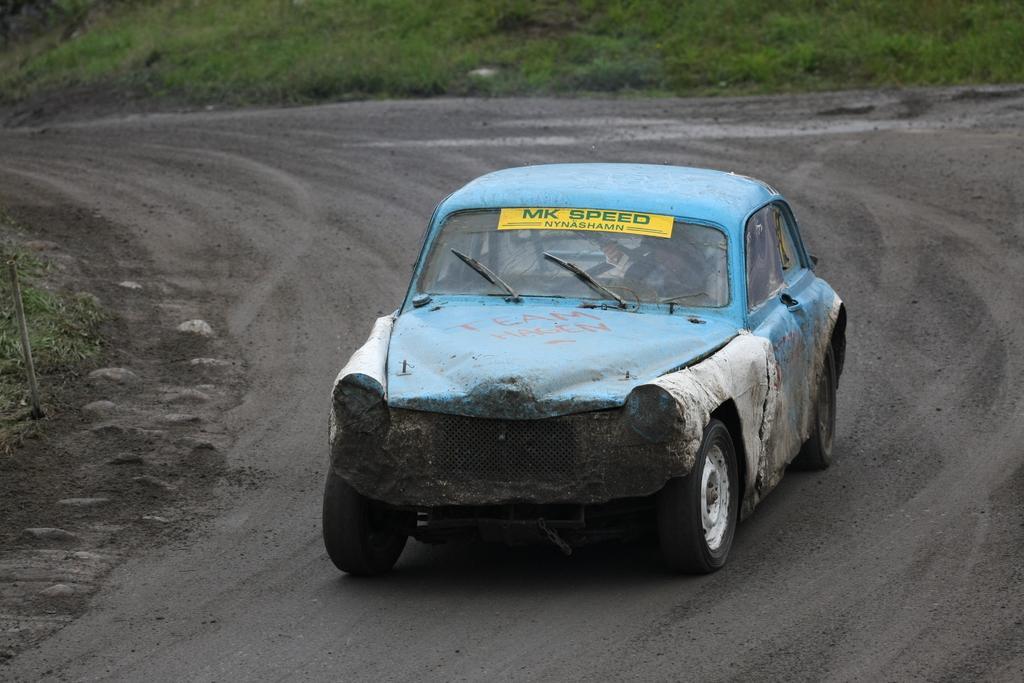How would you summarize this image in a sentence or two? In this picture, we see the blue car is moving on the road. We see a poster or a paper in yellow color with some text written is pasted on the car. On the left side, we see a pole and the grass. At the bottom, we see the road. In the background, we see the grass. 